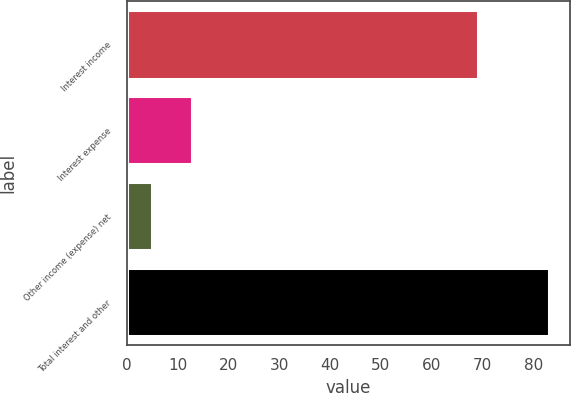Convert chart. <chart><loc_0><loc_0><loc_500><loc_500><bar_chart><fcel>Interest income<fcel>Interest expense<fcel>Other income (expense) net<fcel>Total interest and other<nl><fcel>69<fcel>12.8<fcel>5<fcel>83<nl></chart> 